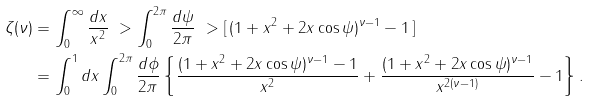<formula> <loc_0><loc_0><loc_500><loc_500>\zeta ( \nu ) & = \int _ { 0 } ^ { \infty } \frac { d x } { x ^ { 2 } } \ > \int _ { 0 } ^ { 2 \pi } \frac { d \psi } { 2 \pi } \ > [ \, ( 1 + x ^ { 2 } + 2 x \cos \psi ) ^ { \nu - 1 } - 1 \, ] \\ & = \int _ { 0 } ^ { 1 } d x \int _ { 0 } ^ { 2 \pi } \frac { d \phi } { 2 \pi } \left \{ \frac { ( 1 + x ^ { 2 } + 2 x \cos \psi ) ^ { \nu - 1 } - 1 } { x ^ { 2 } } + \frac { ( 1 + x ^ { 2 } + 2 x \cos \psi ) ^ { \nu - 1 } } { x ^ { 2 ( \nu - 1 ) } } - 1 \right \} .</formula> 